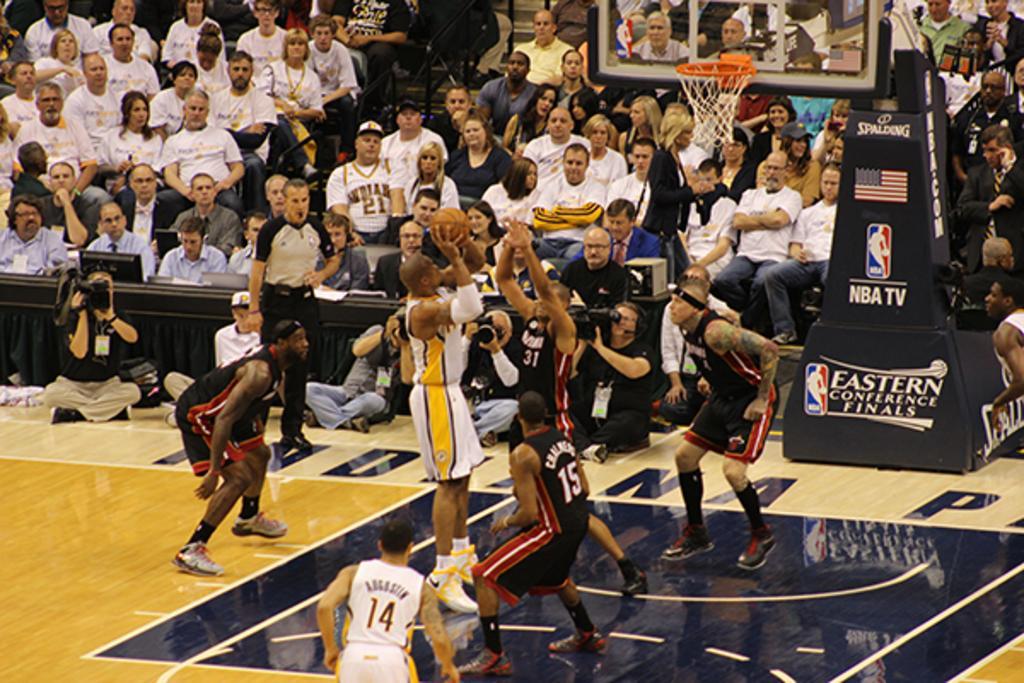Can you describe this image briefly? On the right side of the image we can see some people are wearing the same type of dress and watching the basketball match and one person is capturing the game in camera. In the middle of the image we can see some people are playing basketball. On the left side of the image we can see some persons are watching basketball match. 